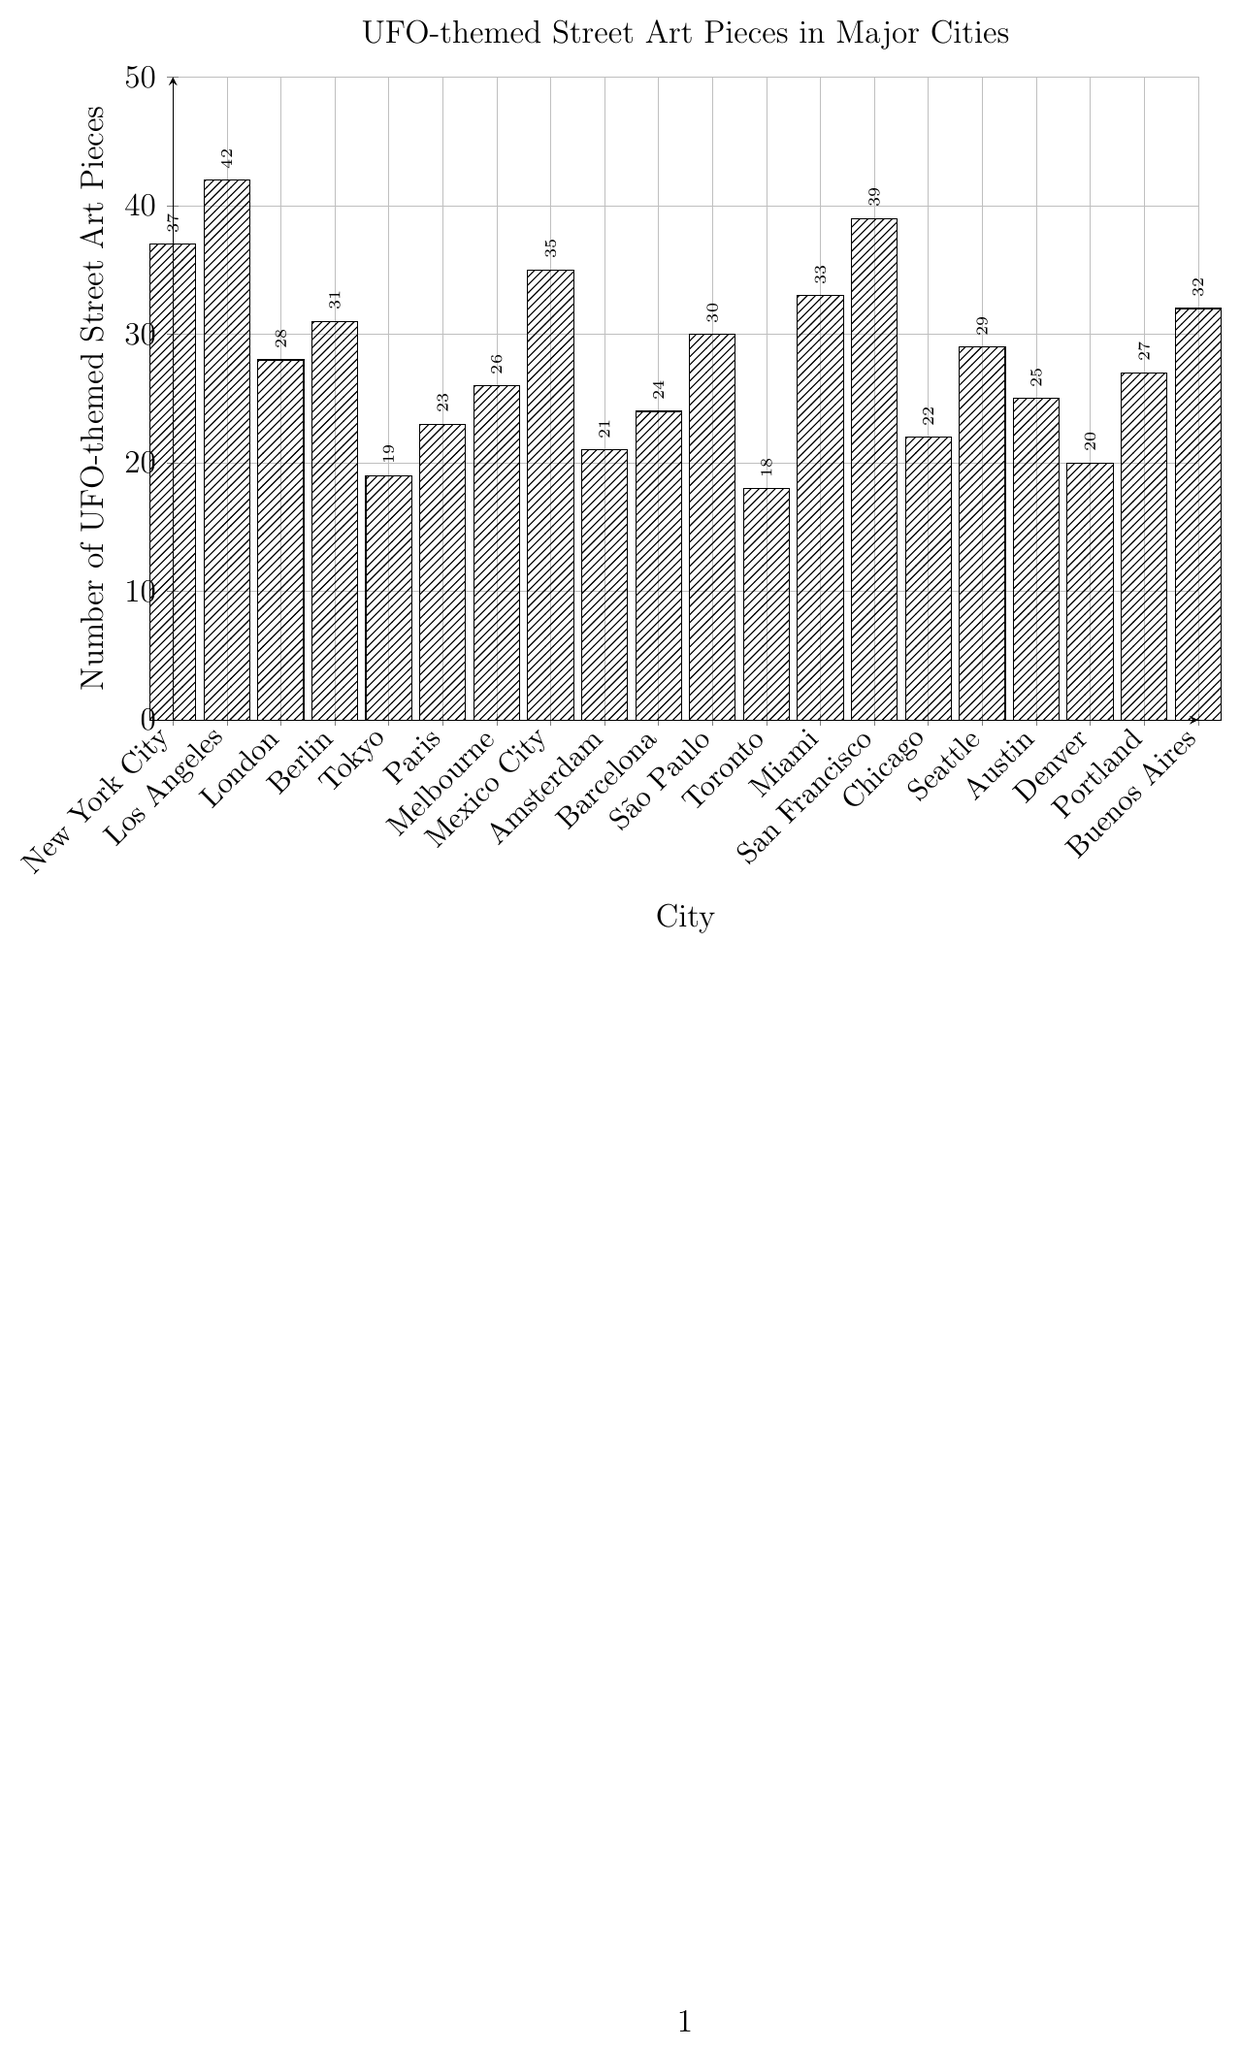What city has the highest number of UFO-themed street art pieces? When we look at the height of the bars, the one representing Los Angeles is the tallest.
Answer: Los Angeles Which cities have fewer UFO-themed street art pieces than New York City? New York City has 37 pieces. The cities with fewer pieces are London (28), Berlin (31), Tokyo (19), Paris (23), Melbourne (26), Amsterdam (21), Barcelona (24), São Paulo (30), Toronto (18), Chicago (22), Seattle (29), Austin (25), Denver (20), Portland (27), and Buenos Aires (32).
Answer: London, Berlin, Tokyo, Paris, Melbourne, Amsterdam, Barcelona, São Paulo, Toronto, Chicago, Seattle, Austin, Denver, Portland, Buenos Aires How many more UFO-themed street art pieces does San Francisco have compared to Berlin? San Francisco has 39 pieces, and Berlin has 31 pieces. The difference can be calculated as 39 - 31.
Answer: 8 What is the total number of UFO-themed street art pieces in New York City, Los Angeles, and Miami combined? Adding the numbers for New York City (37), Los Angeles (42), and Miami (33) gives us: 37 + 42 + 33.
Answer: 112 Which city has the least number of UFO-themed street art pieces? The bar for Toronto is the shortest, indicating it has the least number.
Answer: Toronto Is the number of UFO-themed street art pieces in Tokyo greater than in Denver? Tokyo has 19 pieces, and Denver has 20 pieces. Since 19 is less than 20, the number in Tokyo is not greater.
Answer: No What is the average number of UFO-themed street art pieces for the listed cities? Summing up all the pieces for each city (42+37+28+31+19+23+26+35+21+24+30+18+33+39+22+29+25+20+27+32 = 561) and dividing by the number of cities (20) gives us 561/20.
Answer: 28.05 Are there more UFO-themed street art pieces in Melbourne or Buenos Aires? Melbourne has 26 pieces, while Buenos Aires has 32 pieces. Since 32 is greater than 26, Buenos Aires has more.
Answer: Buenos Aires Which city has almost the same number of UFO-themed street art pieces as Barcelona? Barcelona has 24 pieces, and Paris, which has 23 pieces, has a count that is closest to 24.
Answer: Paris What's the median number of UFO-themed street art pieces across the cities? First, the numbers must be ordered: 18, 19, 20, 21, 22, 23, 24, 25, 26, 27, 28, 29, 30, 31, 32, 33, 35, 37, 39, 42. The median is the average of the 10th and 11th values: (27 + 28) / 2.
Answer: 27.5 